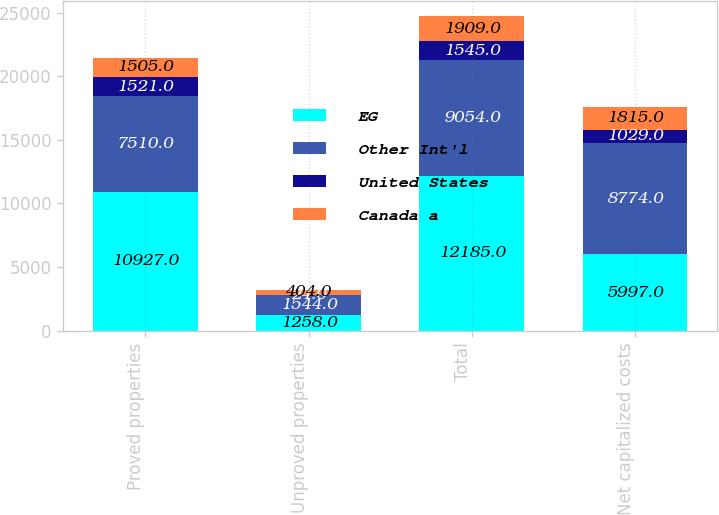Convert chart to OTSL. <chart><loc_0><loc_0><loc_500><loc_500><stacked_bar_chart><ecel><fcel>Proved properties<fcel>Unproved properties<fcel>Total<fcel>Net capitalized costs<nl><fcel>EG<fcel>10927<fcel>1258<fcel>12185<fcel>5997<nl><fcel>Other Int'l<fcel>7510<fcel>1544<fcel>9054<fcel>8774<nl><fcel>United States<fcel>1521<fcel>24<fcel>1545<fcel>1029<nl><fcel>Canada a<fcel>1505<fcel>404<fcel>1909<fcel>1815<nl></chart> 